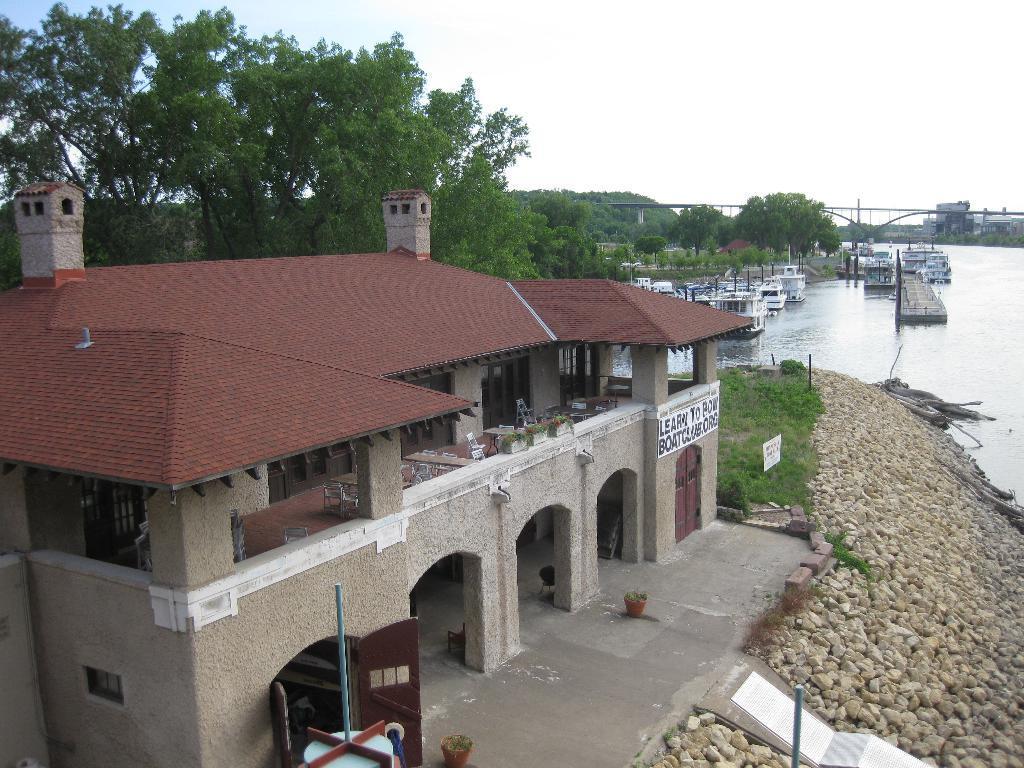Can you describe this image briefly? At the bottom of the image there is a building with walls, roofs, pillars, arches, doors and chimneys. On the walls there is text with paintings. In front of the building there are stones and also there is grass. Beside the stone there is water. On the water there are boats. Above the water there is a bridge. In the background there are trees. Behind the bridge there are buildings. At the top of the image there is sky. 